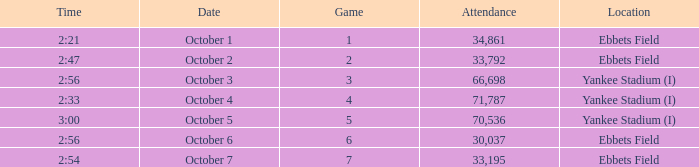Yankee stadium (i), and a time of 3:00 has what attendance for this location? 70536.0. 